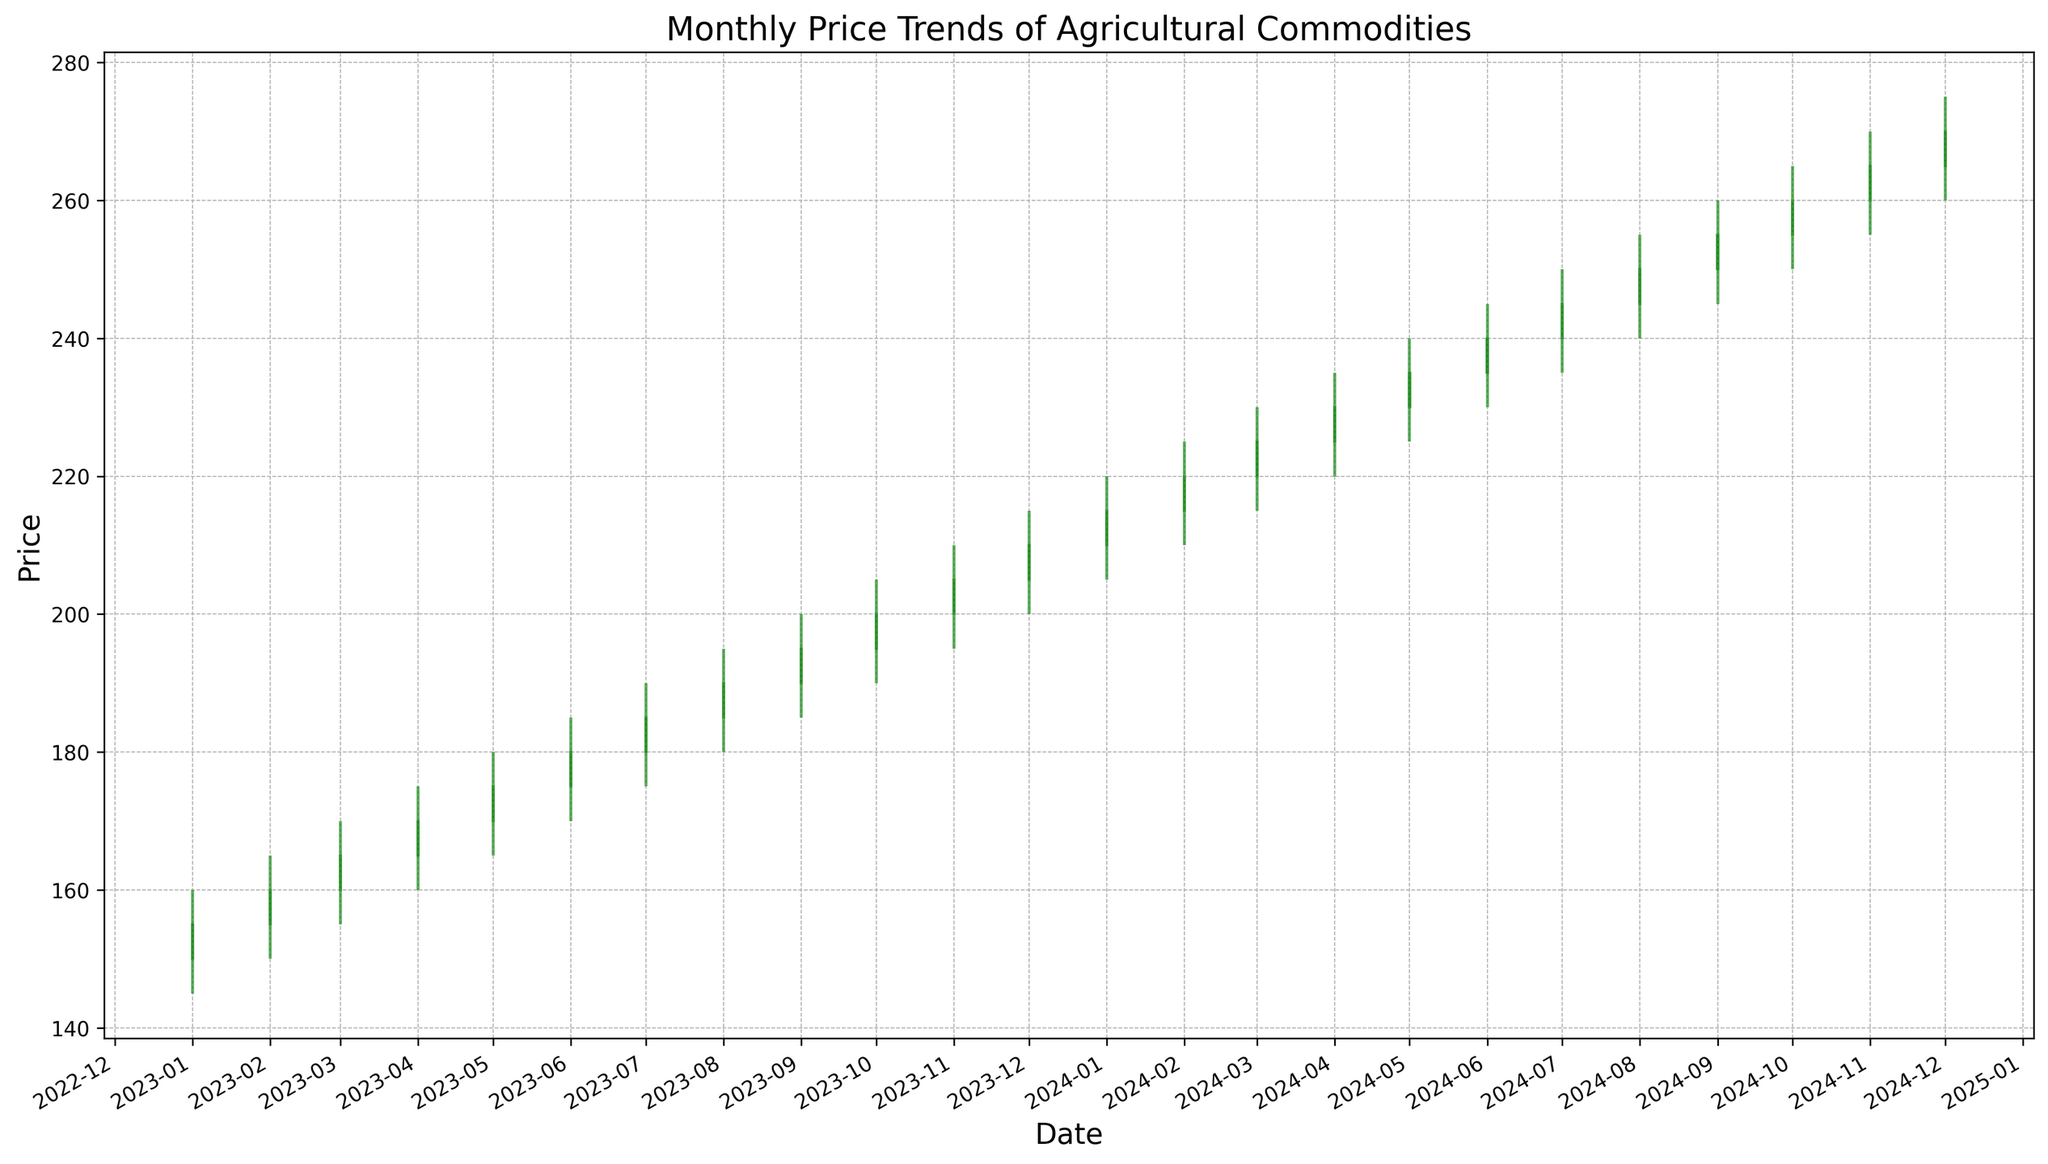What is the overall trend in the prices of agricultural commodities over the two-year period? By observing the candlestick patterns from January 2023 to December 2024, it's clear that the closing prices generally increase month-over-month, indicating an overall upward trend.
Answer: Upward trend Which month experienced the highest trading volume in the given period? By looking at the stick charts, December 2024 shows the longest vertical bar representing the highest volume of 7200.
Answer: December 2024 During which month was the lowest price recorded in the two-year period? Examining the shadows (wicks) of the candlesticks, the lowest price was recorded in January 2023, seen by the shadow touching the 145 mark on the y-axis.
Answer: January 2023 How much did the closing price increase by from January 2023 to December 2024? The closing price in January 2023 is 155, and in December 2024 it is 270. The increase is calculated as 270 - 155 = 115.
Answer: 115 Which month had the largest difference between the highest and lowest prices? Observing the length of the candlestick wicks, December 2024 shows the largest difference between the high of 275 and the low of 260, which is a difference of 15.
Answer: December 2024 Which color represents the months where the agricultural commodity prices rose? Green candlesticks are used to represent the months where the closing price was higher than the opening price.
Answer: Green Which month had a decline in the closing price compared to the previous month? By comparing the closing prices month over month, there is no drop; each closing price is either stable or greater than the previous month's closing price.
Answer: None What was the highest closing price recorded, and in which month did it occur? The highest closing price is observed at the top of the last green candlestick in December 2024 at the close value of 270.
Answer: 270, December 2024 What was the average closing price over the two-year period? The sum of all the closing prices is 5055. Dividing by 24 months, the average closing price is 5055 / 24 ≈ 210.625.
Answer: Approximately 210.63 